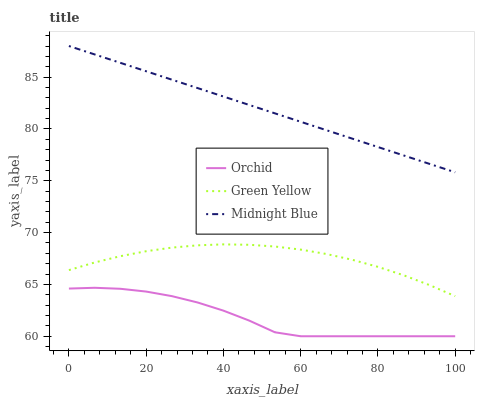Does Orchid have the minimum area under the curve?
Answer yes or no. Yes. Does Midnight Blue have the maximum area under the curve?
Answer yes or no. Yes. Does Midnight Blue have the minimum area under the curve?
Answer yes or no. No. Does Orchid have the maximum area under the curve?
Answer yes or no. No. Is Midnight Blue the smoothest?
Answer yes or no. Yes. Is Orchid the roughest?
Answer yes or no. Yes. Is Orchid the smoothest?
Answer yes or no. No. Is Midnight Blue the roughest?
Answer yes or no. No. Does Midnight Blue have the lowest value?
Answer yes or no. No. Does Orchid have the highest value?
Answer yes or no. No. Is Green Yellow less than Midnight Blue?
Answer yes or no. Yes. Is Midnight Blue greater than Green Yellow?
Answer yes or no. Yes. Does Green Yellow intersect Midnight Blue?
Answer yes or no. No. 